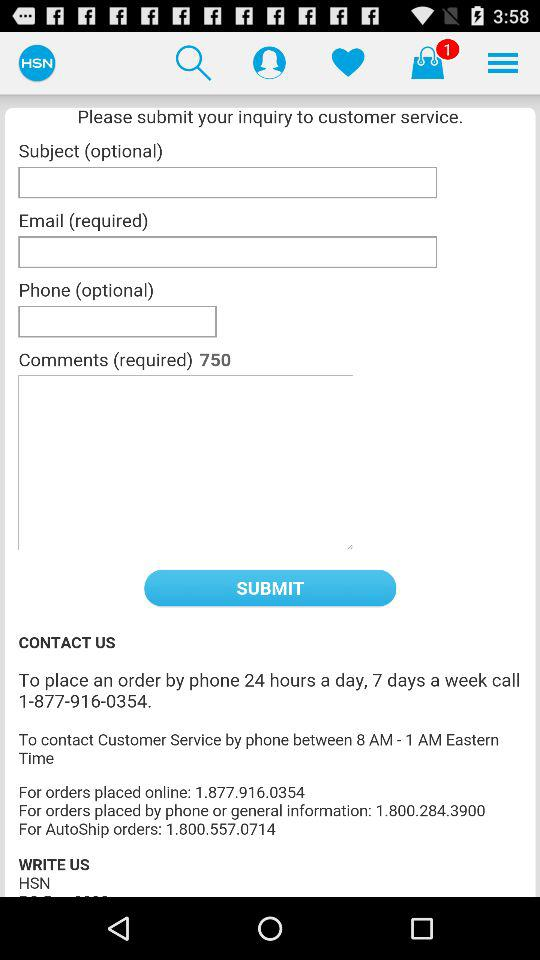What is the contact number for autoship orders? The contact number for autoship orders is 1.800.557.0714. 